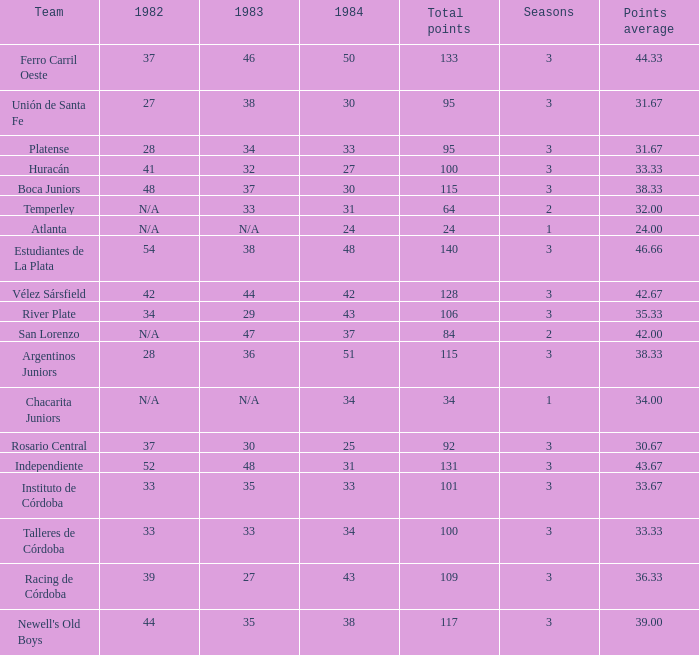What is the sum for 1984 for the team with 100 points in total and more than 3 seasons? None. 